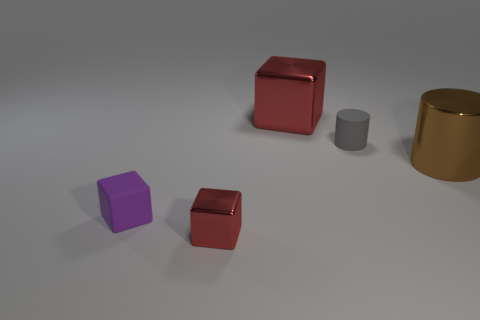Are there any big metal objects that are in front of the metal object that is behind the brown metallic thing?
Make the answer very short. Yes. Are there more large brown metal cylinders that are behind the small red object than large metal cubes that are in front of the small gray thing?
Make the answer very short. Yes. There is a big thing that is the same color as the small metal object; what is its material?
Keep it short and to the point. Metal. What number of big things have the same color as the small matte cube?
Offer a very short reply. 0. Is the color of the block that is behind the small purple matte cube the same as the metal cube in front of the large brown object?
Your response must be concise. Yes. There is a gray cylinder; are there any big metal things left of it?
Offer a very short reply. Yes. What material is the large red thing?
Provide a succinct answer. Metal. What is the shape of the small thing behind the rubber cube?
Offer a very short reply. Cylinder. There is a metallic object that is the same color as the large metal cube; what is its size?
Ensure brevity in your answer.  Small. Are there any blocks that have the same size as the purple thing?
Your answer should be compact. Yes. 